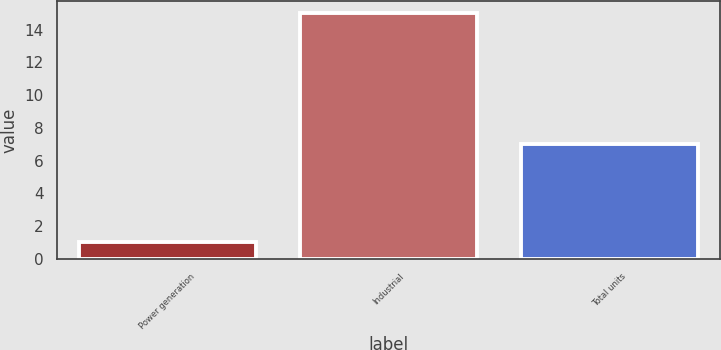Convert chart to OTSL. <chart><loc_0><loc_0><loc_500><loc_500><bar_chart><fcel>Power generation<fcel>Industrial<fcel>Total units<nl><fcel>1<fcel>15<fcel>7<nl></chart> 